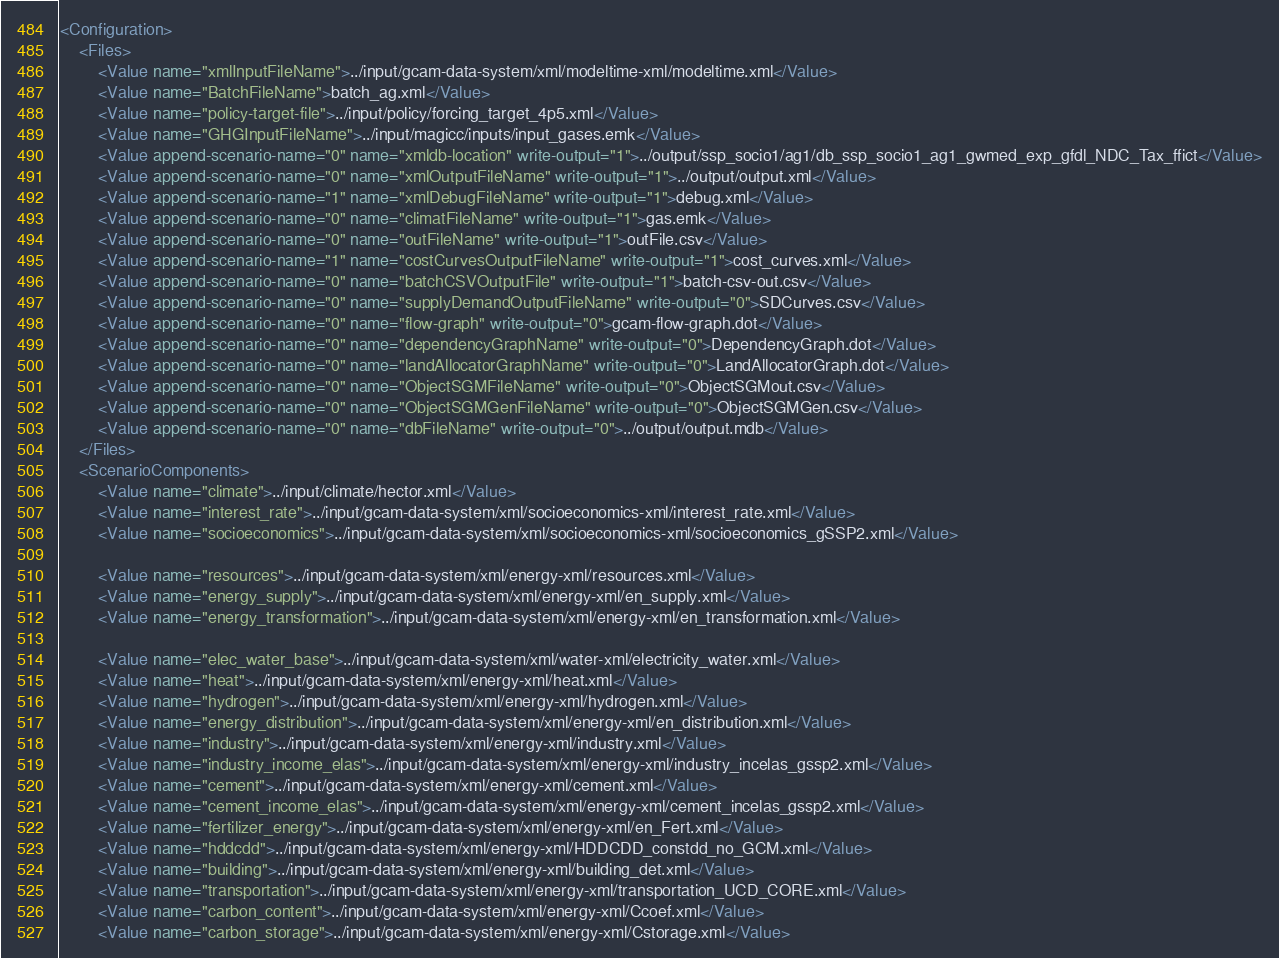Convert code to text. <code><loc_0><loc_0><loc_500><loc_500><_XML_><Configuration>
	<Files>
		<Value name="xmlInputFileName">../input/gcam-data-system/xml/modeltime-xml/modeltime.xml</Value>
		<Value name="BatchFileName">batch_ag.xml</Value>
		<Value name="policy-target-file">../input/policy/forcing_target_4p5.xml</Value>
		<Value name="GHGInputFileName">../input/magicc/inputs/input_gases.emk</Value>
		<Value append-scenario-name="0" name="xmldb-location" write-output="1">../output/ssp_socio1/ag1/db_ssp_socio1_ag1_gwmed_exp_gfdl_NDC_Tax_ffict</Value>
		<Value append-scenario-name="0" name="xmlOutputFileName" write-output="1">../output/output.xml</Value>
		<Value append-scenario-name="1" name="xmlDebugFileName" write-output="1">debug.xml</Value>
		<Value append-scenario-name="0" name="climatFileName" write-output="1">gas.emk</Value>
		<Value append-scenario-name="0" name="outFileName" write-output="1">outFile.csv</Value>
		<Value append-scenario-name="1" name="costCurvesOutputFileName" write-output="1">cost_curves.xml</Value>
		<Value append-scenario-name="0" name="batchCSVOutputFile" write-output="1">batch-csv-out.csv</Value>
		<Value append-scenario-name="0" name="supplyDemandOutputFileName" write-output="0">SDCurves.csv</Value>
		<Value append-scenario-name="0" name="flow-graph" write-output="0">gcam-flow-graph.dot</Value>
		<Value append-scenario-name="0" name="dependencyGraphName" write-output="0">DependencyGraph.dot</Value>
		<Value append-scenario-name="0" name="landAllocatorGraphName" write-output="0">LandAllocatorGraph.dot</Value>
		<Value append-scenario-name="0" name="ObjectSGMFileName" write-output="0">ObjectSGMout.csv</Value>
		<Value append-scenario-name="0" name="ObjectSGMGenFileName" write-output="0">ObjectSGMGen.csv</Value>
		<Value append-scenario-name="0" name="dbFileName" write-output="0">../output/output.mdb</Value>
	</Files>
	<ScenarioComponents>
		<Value name="climate">../input/climate/hector.xml</Value>
		<Value name="interest_rate">../input/gcam-data-system/xml/socioeconomics-xml/interest_rate.xml</Value>
		<Value name="socioeconomics">../input/gcam-data-system/xml/socioeconomics-xml/socioeconomics_gSSP2.xml</Value>

		<Value name="resources">../input/gcam-data-system/xml/energy-xml/resources.xml</Value>
		<Value name="energy_supply">../input/gcam-data-system/xml/energy-xml/en_supply.xml</Value>
		<Value name="energy_transformation">../input/gcam-data-system/xml/energy-xml/en_transformation.xml</Value>
		
		<Value name="elec_water_base">../input/gcam-data-system/xml/water-xml/electricity_water.xml</Value>
		<Value name="heat">../input/gcam-data-system/xml/energy-xml/heat.xml</Value>
		<Value name="hydrogen">../input/gcam-data-system/xml/energy-xml/hydrogen.xml</Value>
		<Value name="energy_distribution">../input/gcam-data-system/xml/energy-xml/en_distribution.xml</Value>
		<Value name="industry">../input/gcam-data-system/xml/energy-xml/industry.xml</Value>
		<Value name="industry_income_elas">../input/gcam-data-system/xml/energy-xml/industry_incelas_gssp2.xml</Value>
		<Value name="cement">../input/gcam-data-system/xml/energy-xml/cement.xml</Value>
		<Value name="cement_income_elas">../input/gcam-data-system/xml/energy-xml/cement_incelas_gssp2.xml</Value>
		<Value name="fertilizer_energy">../input/gcam-data-system/xml/energy-xml/en_Fert.xml</Value>
		<Value name="hddcdd">../input/gcam-data-system/xml/energy-xml/HDDCDD_constdd_no_GCM.xml</Value>
		<Value name="building">../input/gcam-data-system/xml/energy-xml/building_det.xml</Value>
		<Value name="transportation">../input/gcam-data-system/xml/energy-xml/transportation_UCD_CORE.xml</Value>
		<Value name="carbon_content">../input/gcam-data-system/xml/energy-xml/Ccoef.xml</Value>
		<Value name="carbon_storage">../input/gcam-data-system/xml/energy-xml/Cstorage.xml</Value>

</code> 